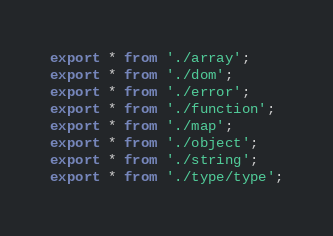Convert code to text. <code><loc_0><loc_0><loc_500><loc_500><_TypeScript_>export * from './array';
export * from './dom';
export * from './error';
export * from './function';
export * from './map';
export * from './object';
export * from './string';
export * from './type/type';
</code> 